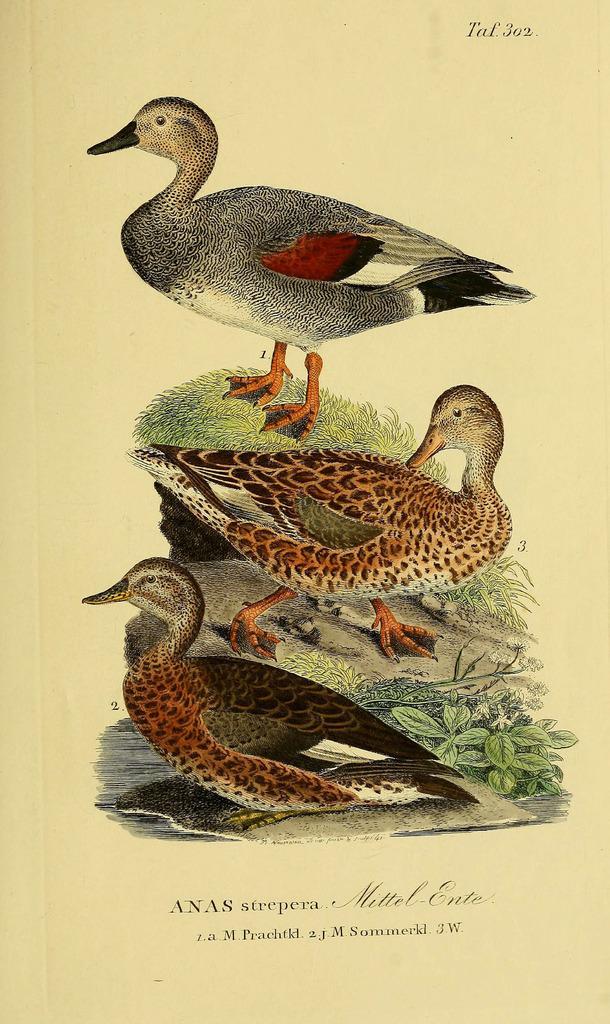In one or two sentences, can you explain what this image depicts? In this picture I can see there are three ducks and there is rock, plants and grass on the floor. There is something written at the bottom of the image. 